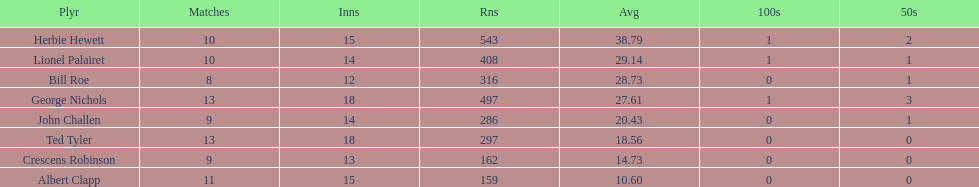What is the least about of runs anyone has? 159. 